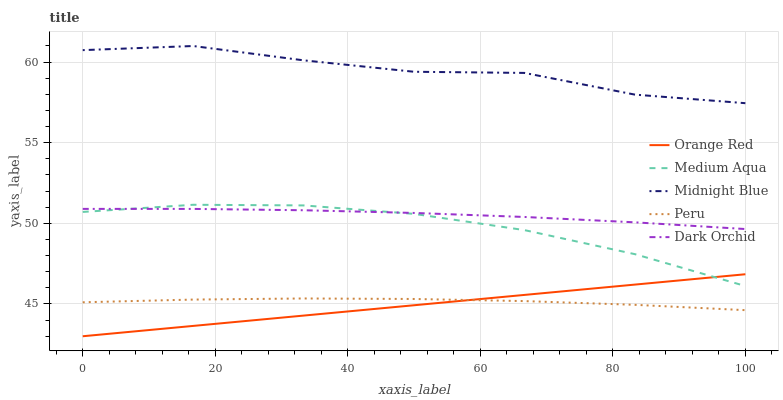Does Orange Red have the minimum area under the curve?
Answer yes or no. Yes. Does Midnight Blue have the maximum area under the curve?
Answer yes or no. Yes. Does Medium Aqua have the minimum area under the curve?
Answer yes or no. No. Does Medium Aqua have the maximum area under the curve?
Answer yes or no. No. Is Orange Red the smoothest?
Answer yes or no. Yes. Is Midnight Blue the roughest?
Answer yes or no. Yes. Is Medium Aqua the smoothest?
Answer yes or no. No. Is Medium Aqua the roughest?
Answer yes or no. No. Does Medium Aqua have the lowest value?
Answer yes or no. No. Does Midnight Blue have the highest value?
Answer yes or no. Yes. Does Medium Aqua have the highest value?
Answer yes or no. No. Is Medium Aqua less than Midnight Blue?
Answer yes or no. Yes. Is Midnight Blue greater than Peru?
Answer yes or no. Yes. Does Dark Orchid intersect Medium Aqua?
Answer yes or no. Yes. Is Dark Orchid less than Medium Aqua?
Answer yes or no. No. Is Dark Orchid greater than Medium Aqua?
Answer yes or no. No. Does Medium Aqua intersect Midnight Blue?
Answer yes or no. No. 